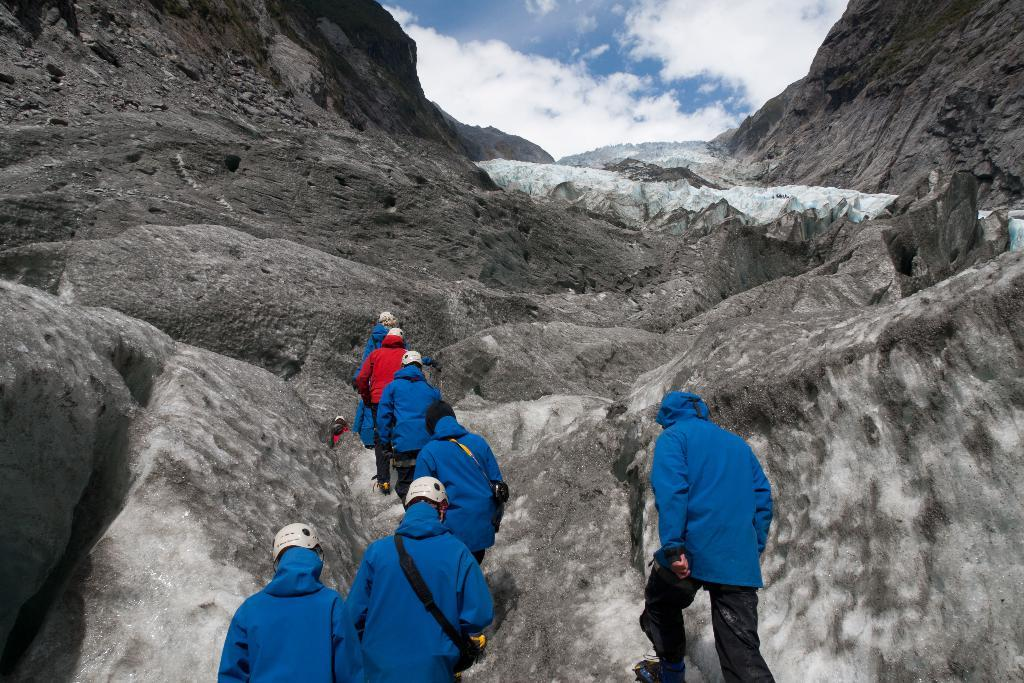How many people are in the image? There are many people in the image. What are some people wearing in the image? Some people are wearing helmets in the image. What type of natural feature can be seen in the image? There are rocks in the image. What is visible in the background of the image? Sky is visible in the background of the image. What can be observed in the sky in the image? Clouds are present in the sky. What time of day is it in the image, based on the voice of the porter? There is no porter or voice present in the image, so it cannot be determined from the image. 